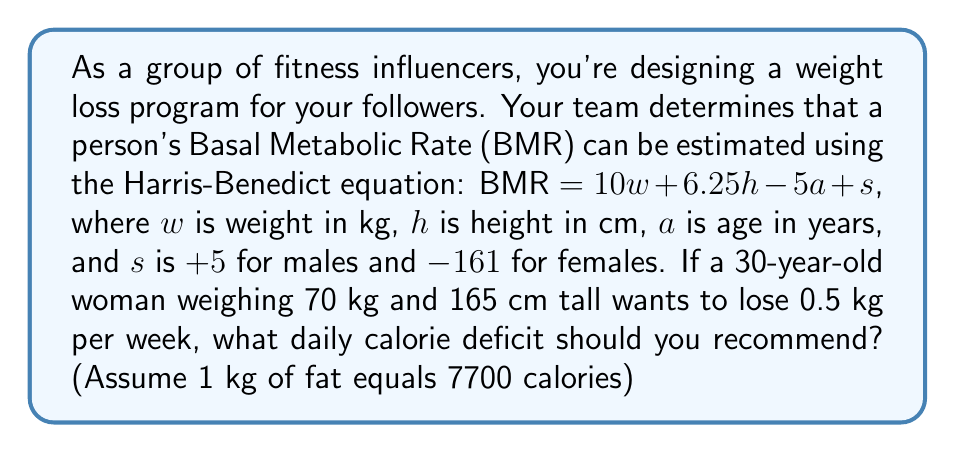Show me your answer to this math problem. Let's approach this step-by-step:

1) First, calculate the woman's BMR using the Harris-Benedict equation:
   $BMR = 10w + 6.25h - 5a + s$
   $BMR = 10(70) + 6.25(165) - 5(30) - 161$
   $BMR = 700 + 1031.25 - 150 - 161$
   $BMR = 1420.25$ calories/day

2) To lose 0.5 kg per week, we need to create a calorie deficit of:
   $0.5 \text{ kg} \times 7700 \text{ calories/kg} = 3850$ calories/week

3) To find the daily calorie deficit, divide by 7:
   $\frac{3850 \text{ calories/week}}{7 \text{ days/week}} = 550$ calories/day

Therefore, the recommended daily calorie deficit is 550 calories.
Answer: 550 calories/day 